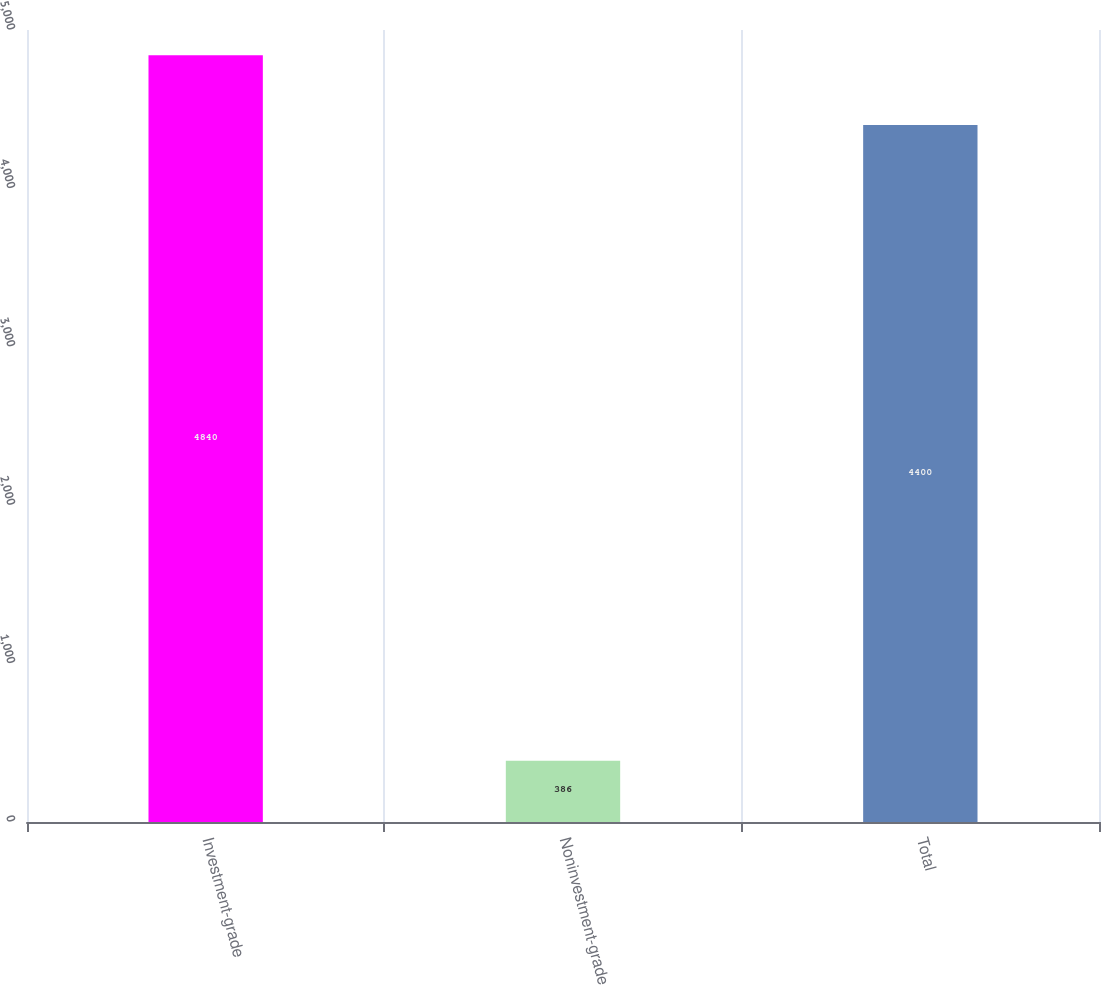Convert chart. <chart><loc_0><loc_0><loc_500><loc_500><bar_chart><fcel>Investment-grade<fcel>Noninvestment-grade<fcel>Total<nl><fcel>4840<fcel>386<fcel>4400<nl></chart> 